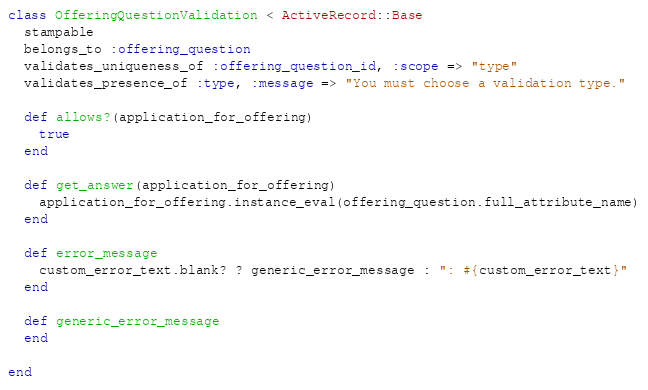<code> <loc_0><loc_0><loc_500><loc_500><_Ruby_>class OfferingQuestionValidation < ActiveRecord::Base
  stampable
  belongs_to :offering_question
  validates_uniqueness_of :offering_question_id, :scope => "type"
  validates_presence_of :type, :message => "You must choose a validation type."
  
  def allows?(application_for_offering)
    true
  end
  
  def get_answer(application_for_offering)
    application_for_offering.instance_eval(offering_question.full_attribute_name)
  end
    
  def error_message
    custom_error_text.blank? ? generic_error_message : ": #{custom_error_text}"
  end
  
  def generic_error_message
  end
  
end
</code> 